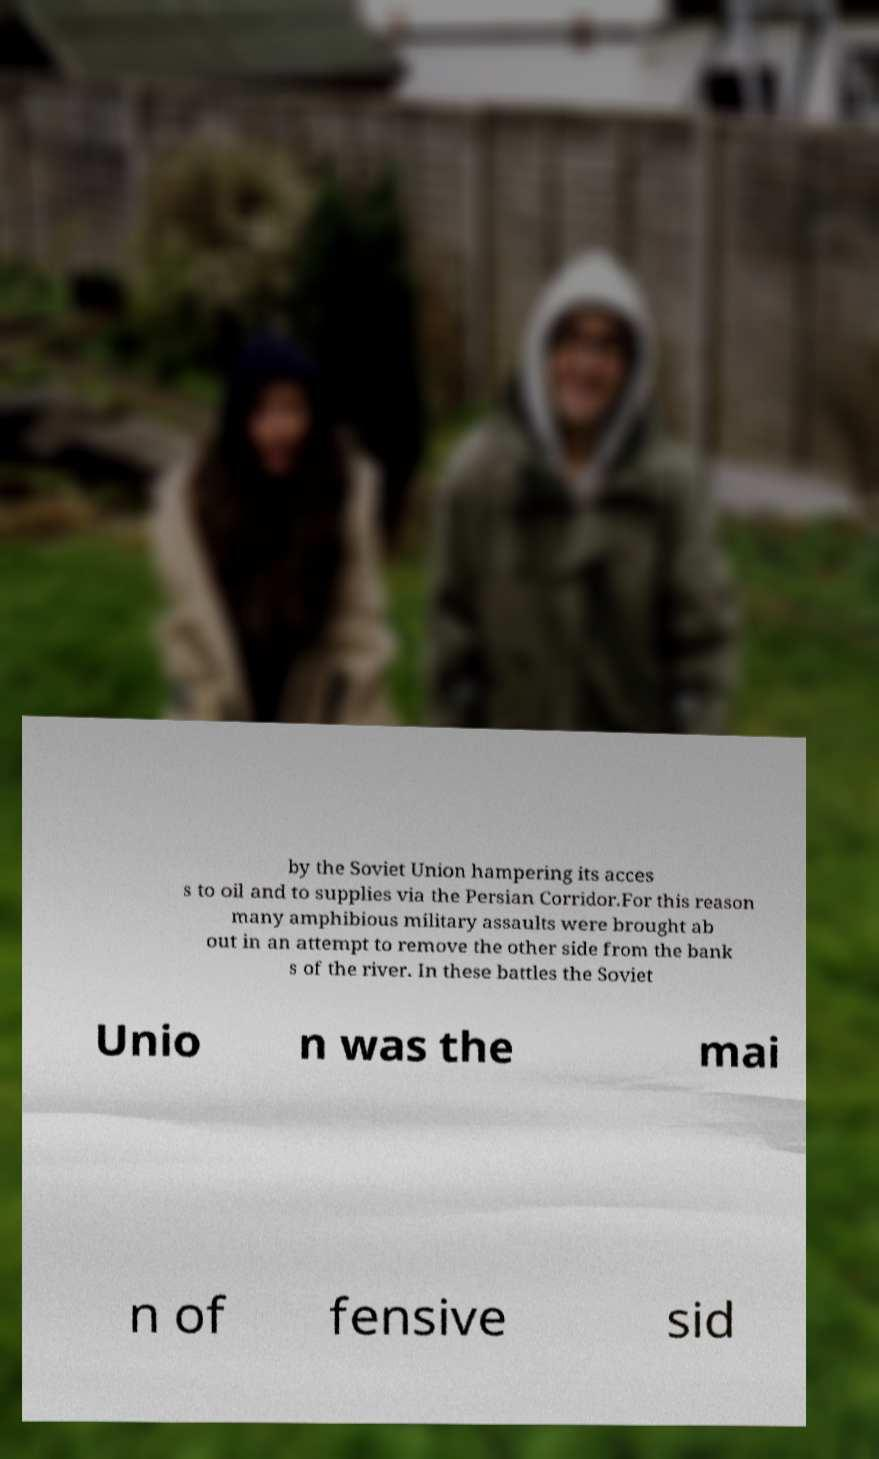What messages or text are displayed in this image? I need them in a readable, typed format. by the Soviet Union hampering its acces s to oil and to supplies via the Persian Corridor.For this reason many amphibious military assaults were brought ab out in an attempt to remove the other side from the bank s of the river. In these battles the Soviet Unio n was the mai n of fensive sid 